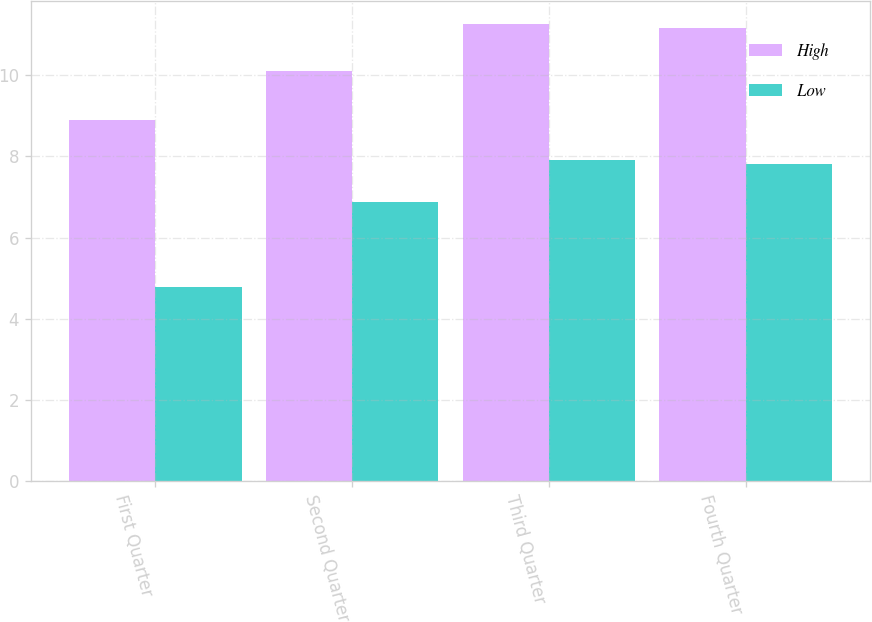Convert chart to OTSL. <chart><loc_0><loc_0><loc_500><loc_500><stacked_bar_chart><ecel><fcel>First Quarter<fcel>Second Quarter<fcel>Third Quarter<fcel>Fourth Quarter<nl><fcel>High<fcel>8.89<fcel>10.1<fcel>11.25<fcel>11.15<nl><fcel>Low<fcel>4.78<fcel>6.87<fcel>7.9<fcel>7.8<nl></chart> 